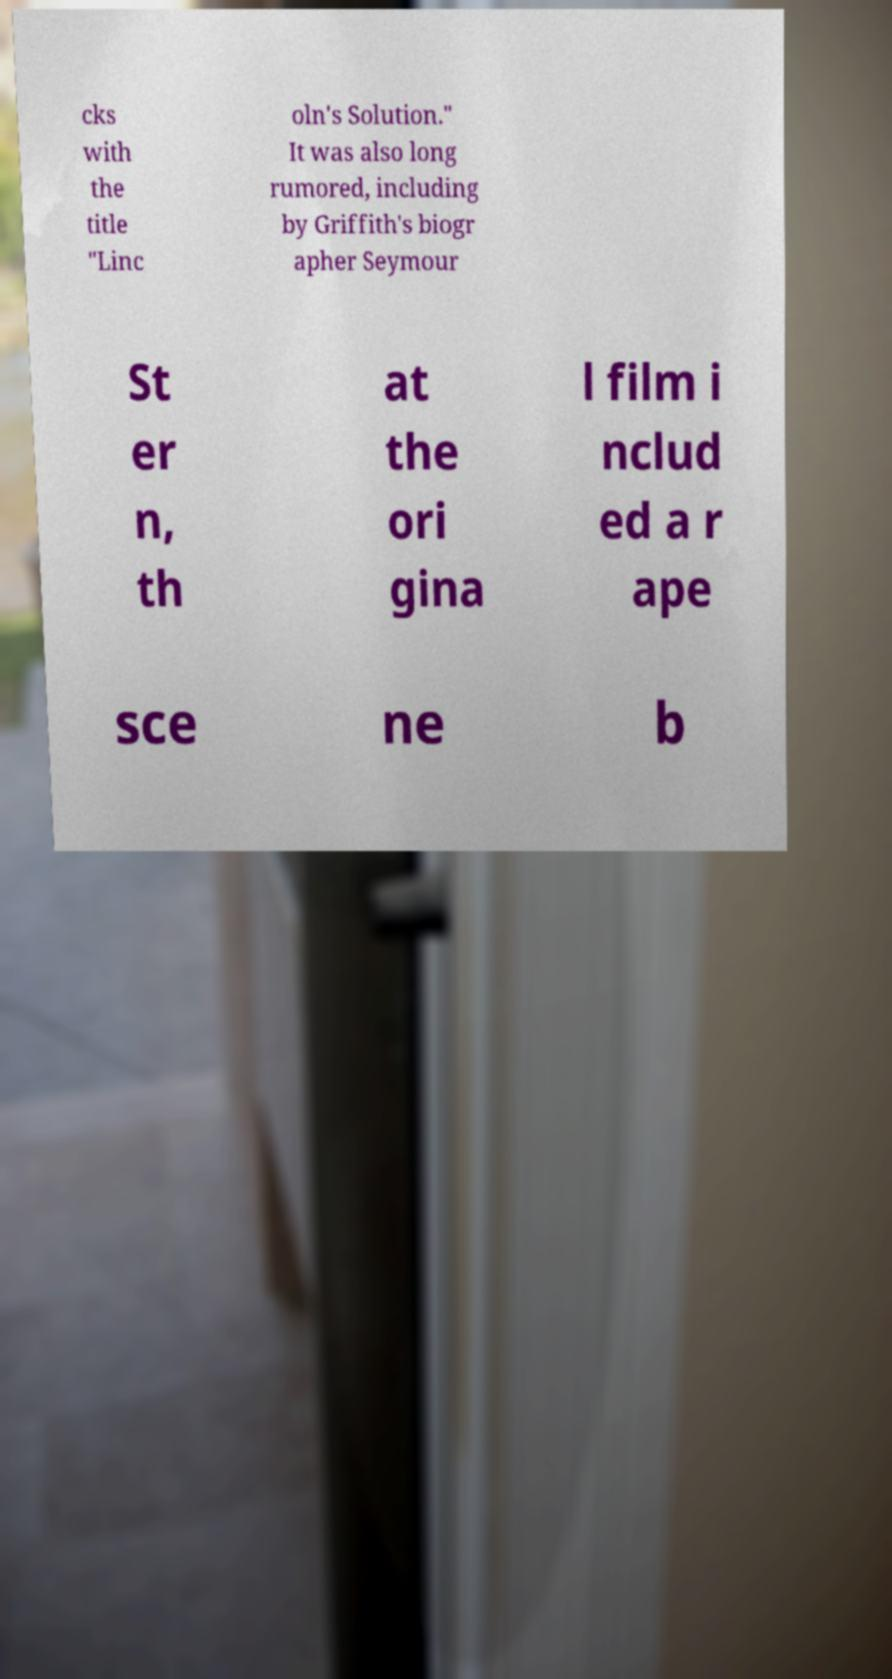Could you extract and type out the text from this image? cks with the title "Linc oln's Solution." It was also long rumored, including by Griffith's biogr apher Seymour St er n, th at the ori gina l film i nclud ed a r ape sce ne b 